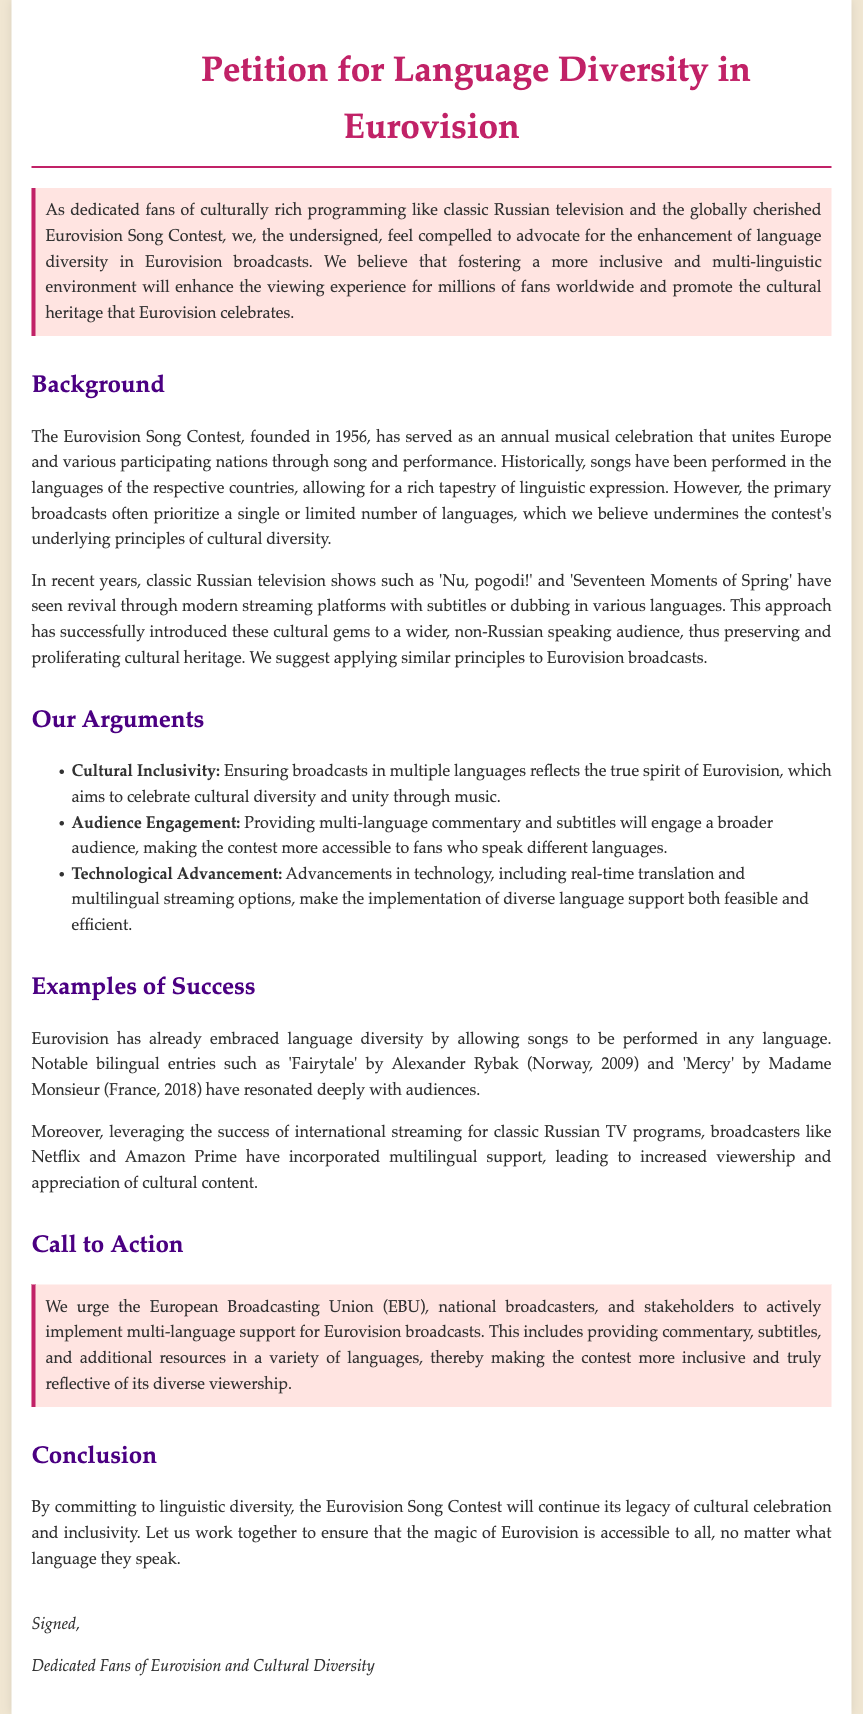What is the title of the petition? The title is displayed prominently at the top of the document, indicating the purpose and focus of the petition.
Answer: Petition for Language Diversity in Eurovision When was the Eurovision Song Contest founded? The document states the founding year of the Eurovision Song Contest within the background section.
Answer: 1956 What example of a classic Russian television show is mentioned? The document provides specific examples of classic Russian shows that have been revived and are referenced in relation to language diversity.
Answer: Nu, pogodi! What is one of the key arguments for language diversity? The document lists several arguments in favor of language diversity, highlighting its importance for the Eurovision Song Contest.
Answer: Cultural Inclusivity Which organization does the petition urge to implement multi-language support? The petition calls on key stakeholders to take action regarding the suggested changes in transmission language support.
Answer: European Broadcasting Union (EBU) What kind of entries have resonated deeply with audiences according to the document? The document mentions specific examples of bilingual entries that were well-received in Eurovision history.
Answer: Bilingual entries How do international streaming platforms contribute to language diversity according to the petition? The document notes the impact of streaming services in incorporating multilingual support for cultural content.
Answer: Increased viewership What is the call to action stated in the petition? The document highlights a specific request aimed at stakeholders for enhancing language diversity.
Answer: Actively implement multi-language support 